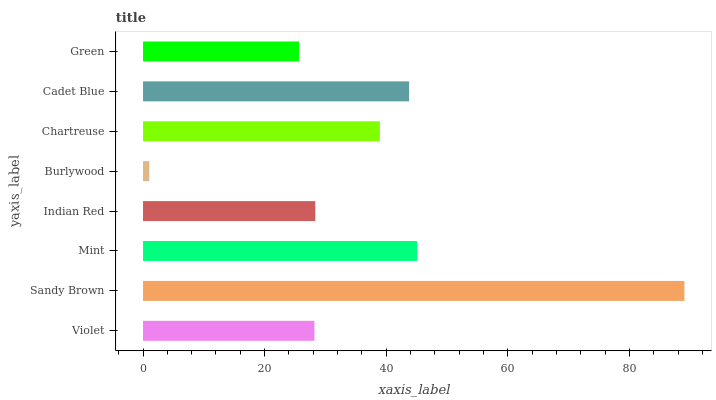Is Burlywood the minimum?
Answer yes or no. Yes. Is Sandy Brown the maximum?
Answer yes or no. Yes. Is Mint the minimum?
Answer yes or no. No. Is Mint the maximum?
Answer yes or no. No. Is Sandy Brown greater than Mint?
Answer yes or no. Yes. Is Mint less than Sandy Brown?
Answer yes or no. Yes. Is Mint greater than Sandy Brown?
Answer yes or no. No. Is Sandy Brown less than Mint?
Answer yes or no. No. Is Chartreuse the high median?
Answer yes or no. Yes. Is Indian Red the low median?
Answer yes or no. Yes. Is Violet the high median?
Answer yes or no. No. Is Burlywood the low median?
Answer yes or no. No. 